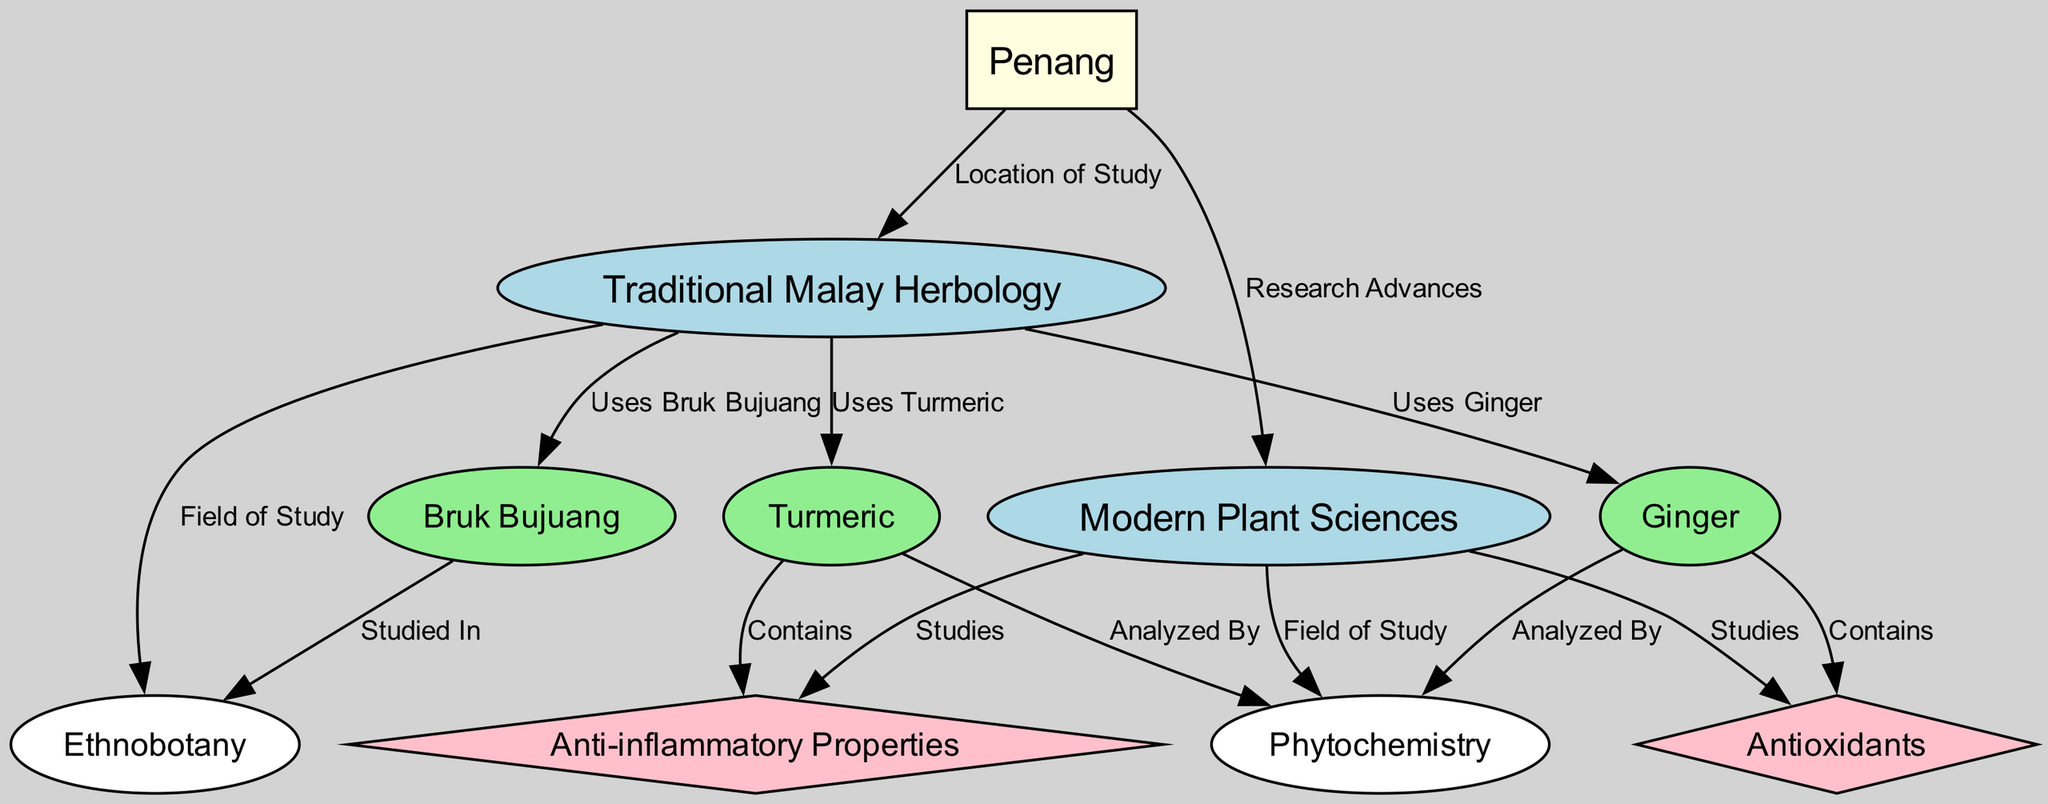What is the main location of study in this diagram? The diagram indicates that Penang is the main location of study as it is directly connected to Traditional Malay Herbology and Modern Plant Sciences. This relationship is illustrated with labeled edges pointing from Penang to each of these two fields.
Answer: Penang Which herb is shown to contain antioxidants? The diagram specifies that Ginger is the herb that contains antioxidants, indicated by its direct connection to the node labeled "Antioxidants".
Answer: Ginger How many nodes are connected to Traditional Malay Herbology? The diagram shows that there are four nodes connected to Traditional Malay Herbology: Bruk Bujuang, Turmeric, Ginger, and Ethnobotany, which can be counted through the direct edges leading from the Traditional Malay Herbology node.
Answer: 4 What type of properties does Turmeric have according to the diagram? The connection from Turmeric to the "Anti-inflammatory Properties" node indicates that it has anti-inflammatory properties, as denoted by the edge labeled "Contains".
Answer: Anti-inflammatory Properties What is the field of study for Modern Plant Sciences? The diagram shows that Modern Plant Sciences is connected to the "Phytochemistry" node, indicating that phytochemistry is a field of study within this domain, as demonstrated by the directed edge labeled "Field of Study".
Answer: Phytochemistry Which traditional herb is specifically studied in ethnobotany? From the diagram, it can be seen that Bruk Bujuang is specifically studied in ethnobotany, as indicated by the edge that connects Bruk Bujuang to the Ethnobotany node labeled "Studied In".
Answer: Bruk Bujuang Do both Traditional Malay Herbology and Modern Plant Sciences study anti-inflammatory properties? Yes, both fields have connections to the "Anti-inflammatory Properties" node; Traditional Malay Herbology links directly to Turmeric, which contains these properties, and Modern Plant Sciences conducts studies on them, as reflected in the edges directed toward the anti-inflammatory properties node.
Answer: Yes How is Ginger analyzed according to the diagram? The diagram indicates that Ginger is analyzed by the field of Phytochemistry. This is shown through the edge labeled "Analyzed By", which connects Ginger to the Phytochemistry node.
Answer: Analyzed By Phytochemistry 